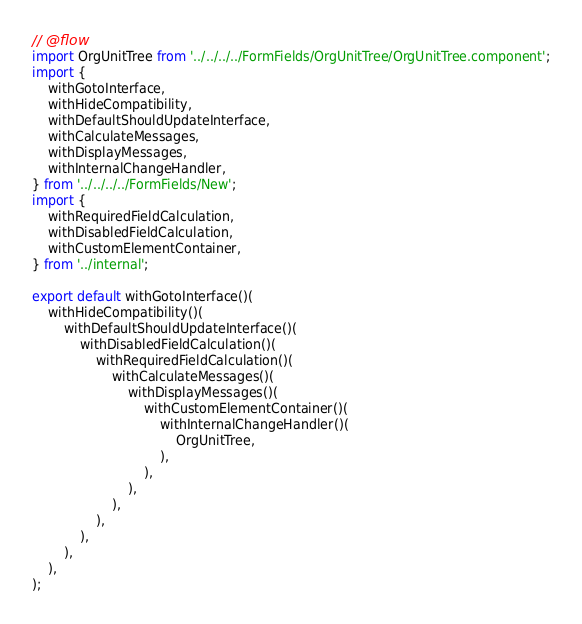Convert code to text. <code><loc_0><loc_0><loc_500><loc_500><_JavaScript_>// @flow
import OrgUnitTree from '../../../../FormFields/OrgUnitTree/OrgUnitTree.component';
import {
    withGotoInterface,
    withHideCompatibility,
    withDefaultShouldUpdateInterface,
    withCalculateMessages,
    withDisplayMessages,
    withInternalChangeHandler,
} from '../../../../FormFields/New';
import {
    withRequiredFieldCalculation,
    withDisabledFieldCalculation,
    withCustomElementContainer,
} from '../internal';

export default withGotoInterface()(
    withHideCompatibility()(
        withDefaultShouldUpdateInterface()(
            withDisabledFieldCalculation()(
                withRequiredFieldCalculation()(
                    withCalculateMessages()(
                        withDisplayMessages()(
                            withCustomElementContainer()(
                                withInternalChangeHandler()(
                                    OrgUnitTree,
                                ),
                            ),
                        ),
                    ),
                ),
            ),
        ),
    ),
);
</code> 